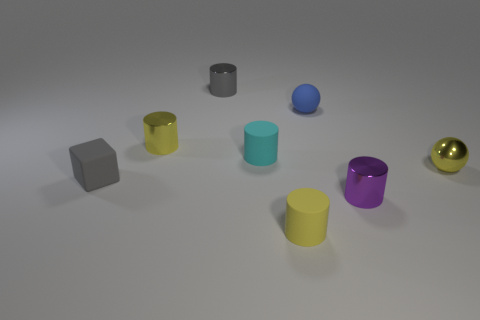Subtract 2 cylinders. How many cylinders are left? 3 Subtract all tiny cyan cylinders. How many cylinders are left? 4 Subtract all cyan cylinders. How many cylinders are left? 4 Subtract all green cylinders. Subtract all purple balls. How many cylinders are left? 5 Add 1 tiny gray metallic cylinders. How many objects exist? 9 Subtract all cylinders. How many objects are left? 3 Subtract all blue rubber things. Subtract all tiny rubber cylinders. How many objects are left? 5 Add 2 cubes. How many cubes are left? 3 Add 4 small red blocks. How many small red blocks exist? 4 Subtract 0 blue blocks. How many objects are left? 8 